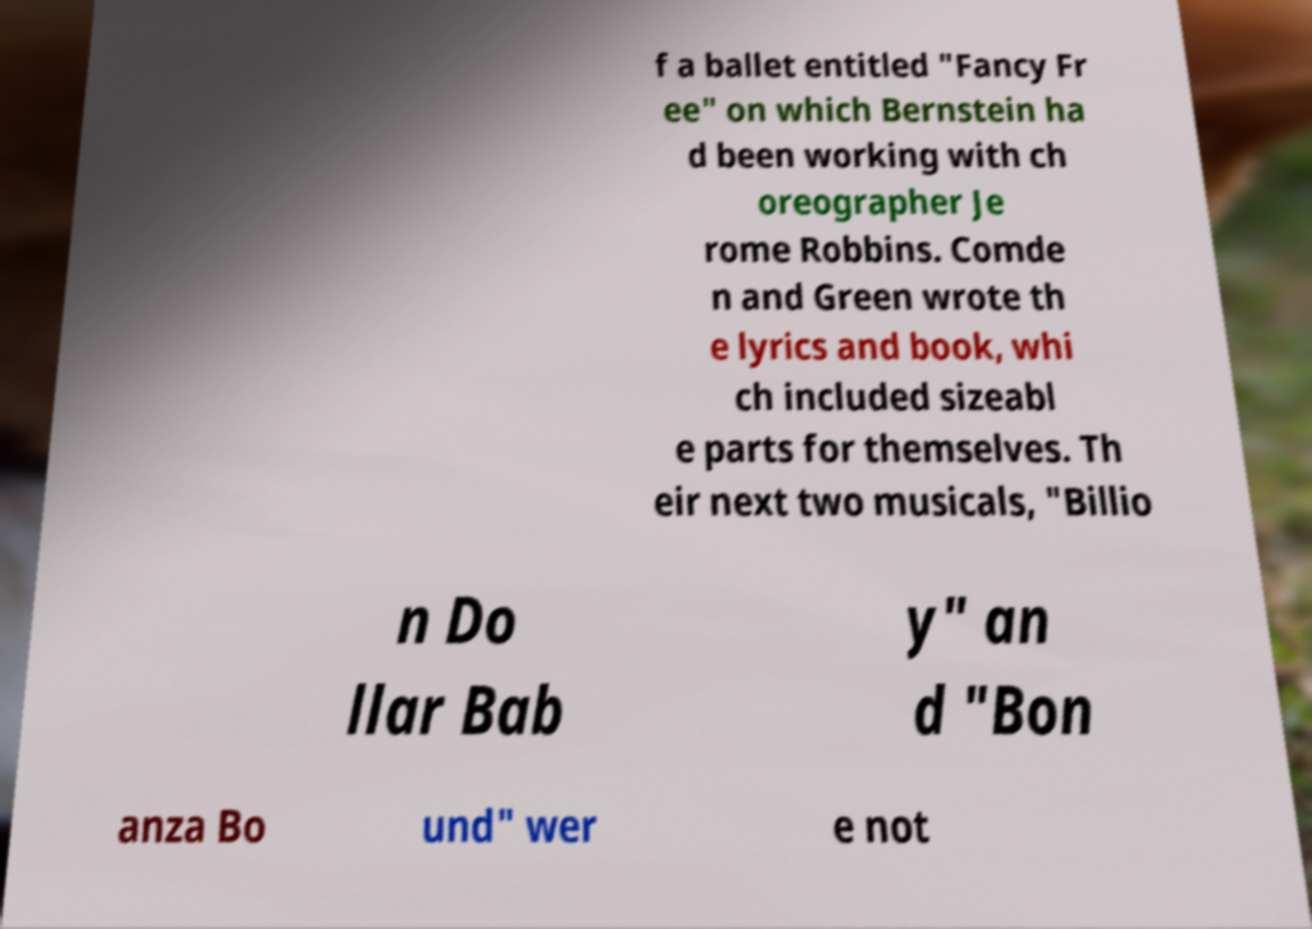Can you read and provide the text displayed in the image?This photo seems to have some interesting text. Can you extract and type it out for me? f a ballet entitled "Fancy Fr ee" on which Bernstein ha d been working with ch oreographer Je rome Robbins. Comde n and Green wrote th e lyrics and book, whi ch included sizeabl e parts for themselves. Th eir next two musicals, "Billio n Do llar Bab y" an d "Bon anza Bo und" wer e not 